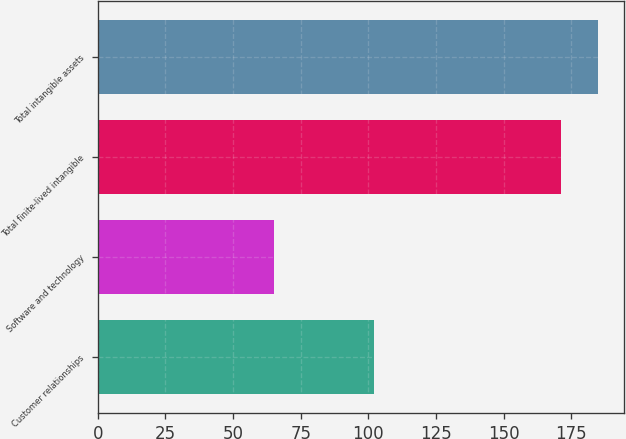<chart> <loc_0><loc_0><loc_500><loc_500><bar_chart><fcel>Customer relationships<fcel>Software and technology<fcel>Total finite-lived intangible<fcel>Total intangible assets<nl><fcel>102<fcel>65<fcel>171<fcel>185<nl></chart> 